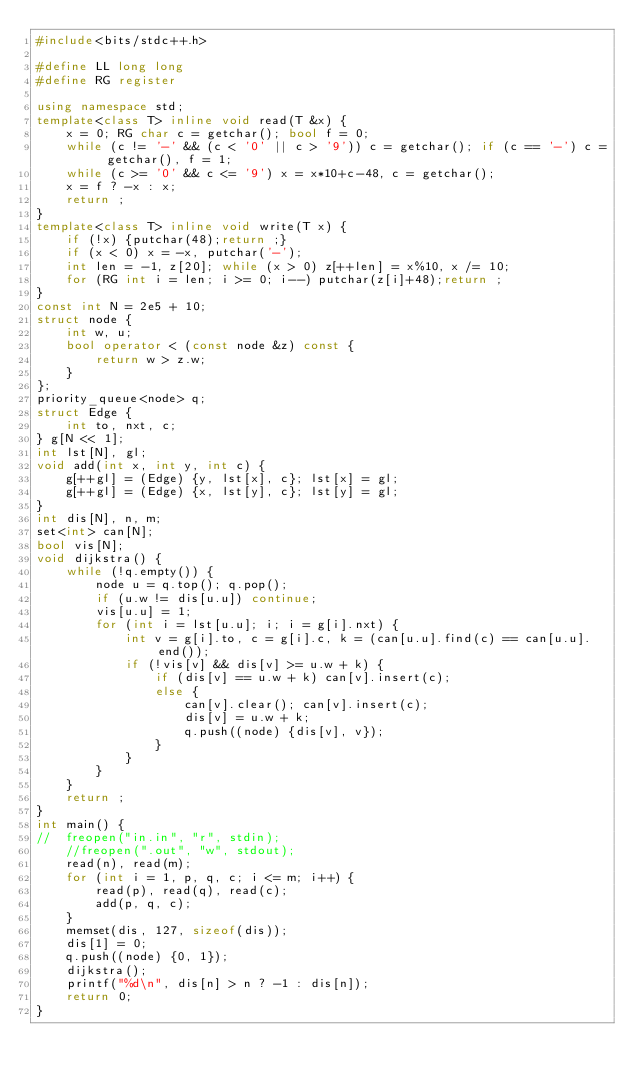<code> <loc_0><loc_0><loc_500><loc_500><_C++_>#include<bits/stdc++.h>

#define LL long long
#define RG register

using namespace std;
template<class T> inline void read(T &x) {
	x = 0; RG char c = getchar(); bool f = 0;
	while (c != '-' && (c < '0' || c > '9')) c = getchar(); if (c == '-') c = getchar(), f = 1;
	while (c >= '0' && c <= '9') x = x*10+c-48, c = getchar();
	x = f ? -x : x;
	return ;
}
template<class T> inline void write(T x) {
	if (!x) {putchar(48);return ;}
	if (x < 0) x = -x, putchar('-');
	int len = -1, z[20]; while (x > 0) z[++len] = x%10, x /= 10;
	for (RG int i = len; i >= 0; i--) putchar(z[i]+48);return ;
}
const int N = 2e5 + 10;
struct node {
	int w, u;
	bool operator < (const node &z) const {
		return w > z.w;
	}
};
priority_queue<node> q;
struct Edge {
	int to, nxt, c;
} g[N << 1];
int lst[N], gl;
void add(int x, int y, int c) {
	g[++gl] = (Edge) {y, lst[x], c}; lst[x] = gl;
	g[++gl] = (Edge) {x, lst[y], c}; lst[y] = gl;
}
int dis[N], n, m;
set<int> can[N];
bool vis[N];
void dijkstra() {
	while (!q.empty()) {
		node u = q.top(); q.pop();
		if (u.w != dis[u.u]) continue;
		vis[u.u] = 1;
		for (int i = lst[u.u]; i; i = g[i].nxt) {
			int v = g[i].to, c = g[i].c, k = (can[u.u].find(c) == can[u.u].end());
			if (!vis[v] && dis[v] >= u.w + k) {
				if (dis[v] == u.w + k) can[v].insert(c);
				else {
					can[v].clear(); can[v].insert(c);
					dis[v] = u.w + k;
					q.push((node) {dis[v], v});
				}
			}
		}
	}
	return ;
}
int main() {
//	freopen("in.in", "r", stdin);
	//freopen(".out", "w", stdout);
	read(n), read(m);
	for (int i = 1, p, q, c; i <= m; i++) {
		read(p), read(q), read(c);
		add(p, q, c);
	}
	memset(dis, 127, sizeof(dis));
	dis[1] = 0;
	q.push((node) {0, 1});
	dijkstra();
	printf("%d\n", dis[n] > n ? -1 : dis[n]);
	return 0;
}
</code> 